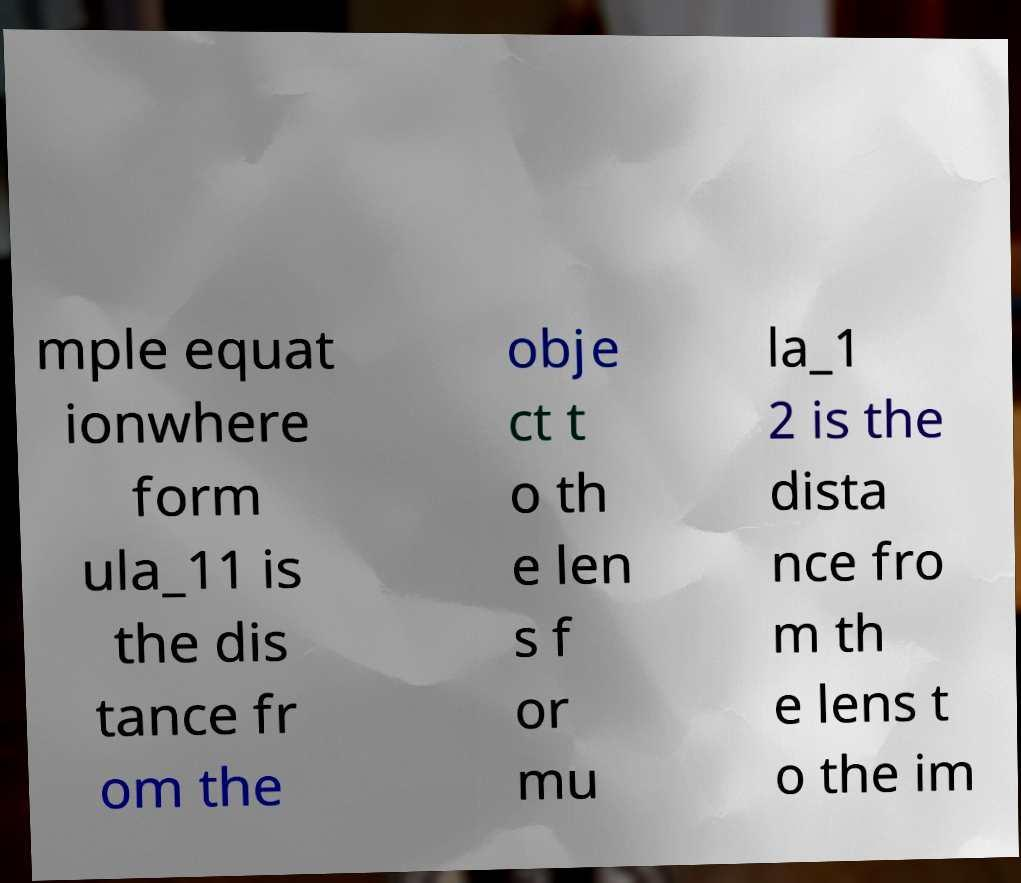Please read and relay the text visible in this image. What does it say? mple equat ionwhere form ula_11 is the dis tance fr om the obje ct t o th e len s f or mu la_1 2 is the dista nce fro m th e lens t o the im 